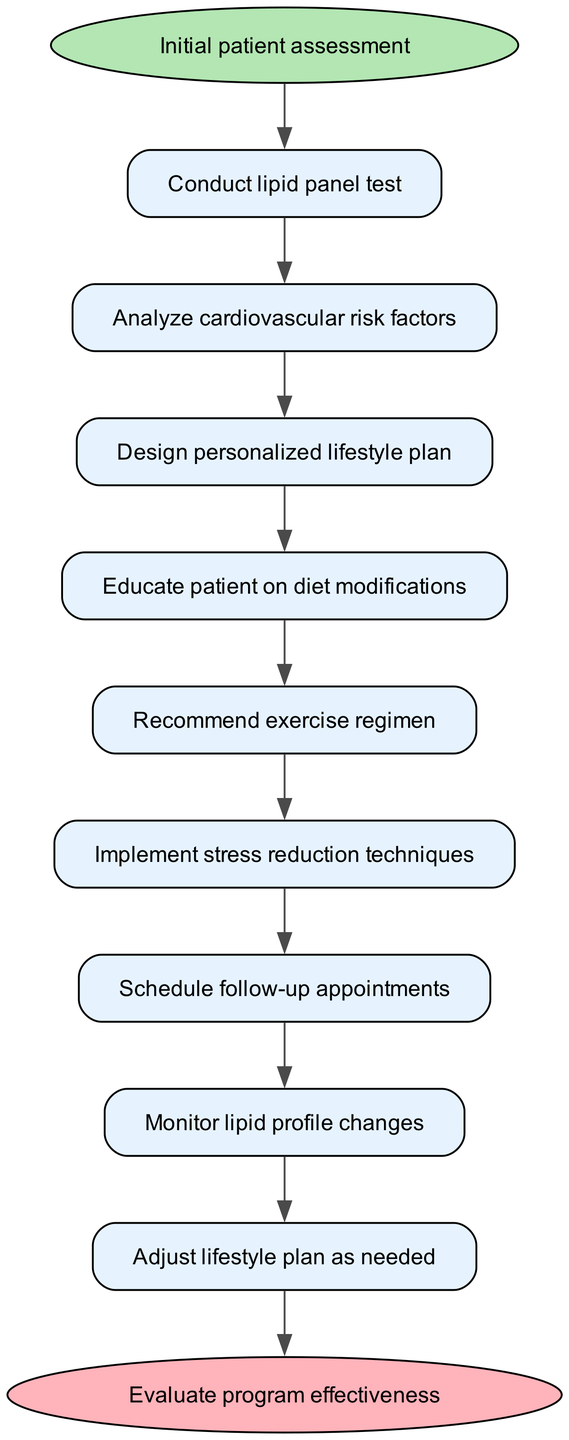What is the first step in the workflow? The first step is "Conduct lipid panel test," which is the immediate action taken after "Initial patient assessment."
Answer: Conduct lipid panel test How many steps are there in total? There are a total of 9 steps listed in the workflow before reaching the end node.
Answer: 9 What is the last action taken before evaluating program effectiveness? The last action is "Adjust lifestyle plan as needed," which directly precedes the end node indicating the evaluation of the program.
Answer: Adjust lifestyle plan as needed Which step follows "Educate patient on diet modifications"? The step that follows is "Recommend exercise regimen," as indicated by the flow from step 4 to step 5 in the diagram.
Answer: Recommend exercise regimen What action should be taken after monitoring lipid profile changes? After monitoring lipid profile changes, the action to take is "Adjust lifestyle plan as needed," as shown by the flow in the diagram.
Answer: Adjust lifestyle plan as needed What type of techniques are implemented at step 6? The techniques implemented are "stress reduction techniques," which emphasizes the importance of managing stress in lifestyle modification.
Answer: stress reduction techniques Which two steps represent educational actions? The educational actions are "Educate patient on diet modifications" (step 4) and "Recommend exercise regimen" (step 5), as both involve imparting knowledge to the patient about lifestyle adjustments.
Answer: Educate patient on diet modifications, Recommend exercise regimen What is the relationship between step 1 and step 2? The relationship is sequential; step 2, "Analyze cardiovascular risk factors," follows step 1, indicating that it occurs after conducting the lipid panel test.
Answer: Sequential What occurs at the end of the workflow? At the end of the workflow, the program is evaluated for its effectiveness, marking the conclusion of the lifestyle modification efforts.
Answer: Evaluate program effectiveness 